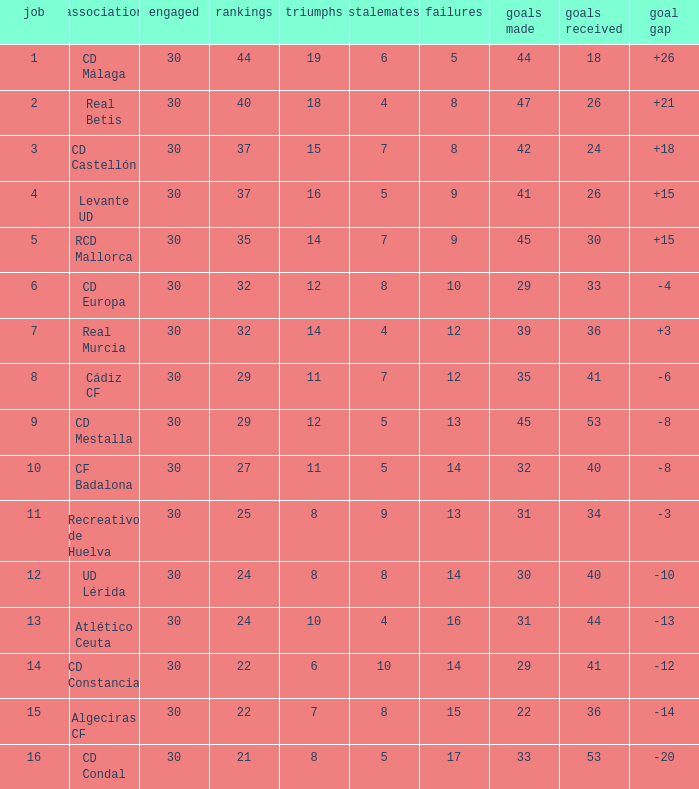What is the number of wins when the goals against is larger than 41, points is 29, and draws are larger than 5? 0.0. 